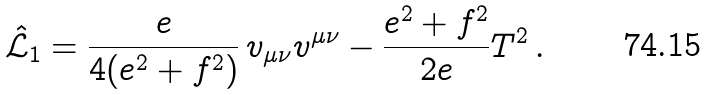<formula> <loc_0><loc_0><loc_500><loc_500>\hat { \mathcal { L } } _ { 1 } = \frac { e } { 4 ( e ^ { 2 } + f ^ { 2 } ) } \, v _ { \mu \nu } v ^ { \mu \nu } - \frac { e ^ { 2 } + f ^ { 2 } } { 2 e } T ^ { 2 } \, .</formula> 